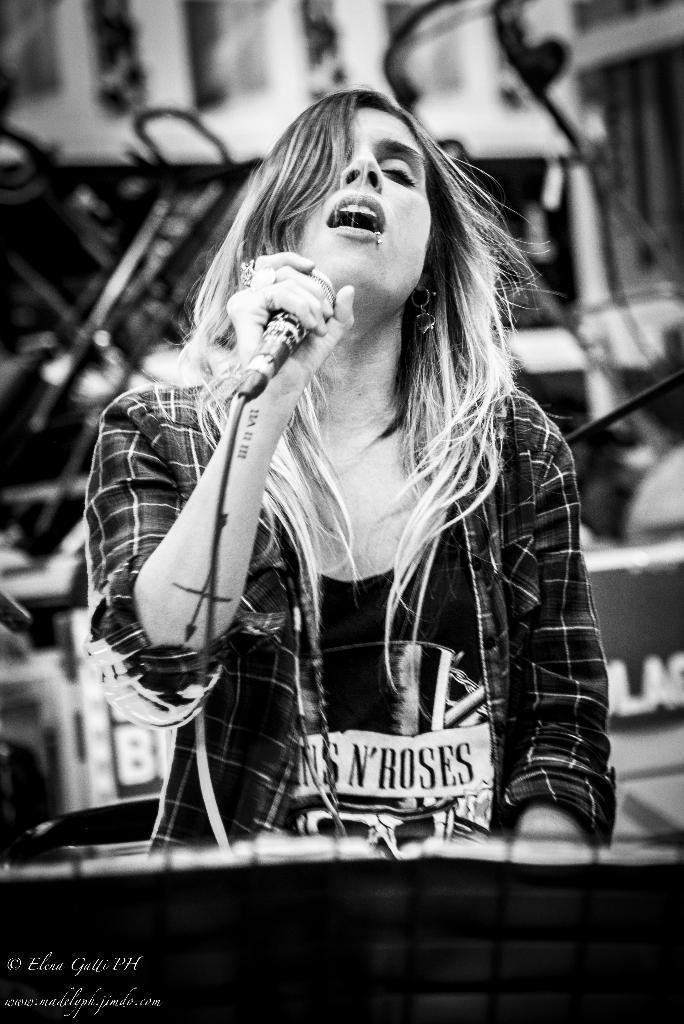In one or two sentences, can you explain what this image depicts? A woman is singing a song with a mic in her hand. 